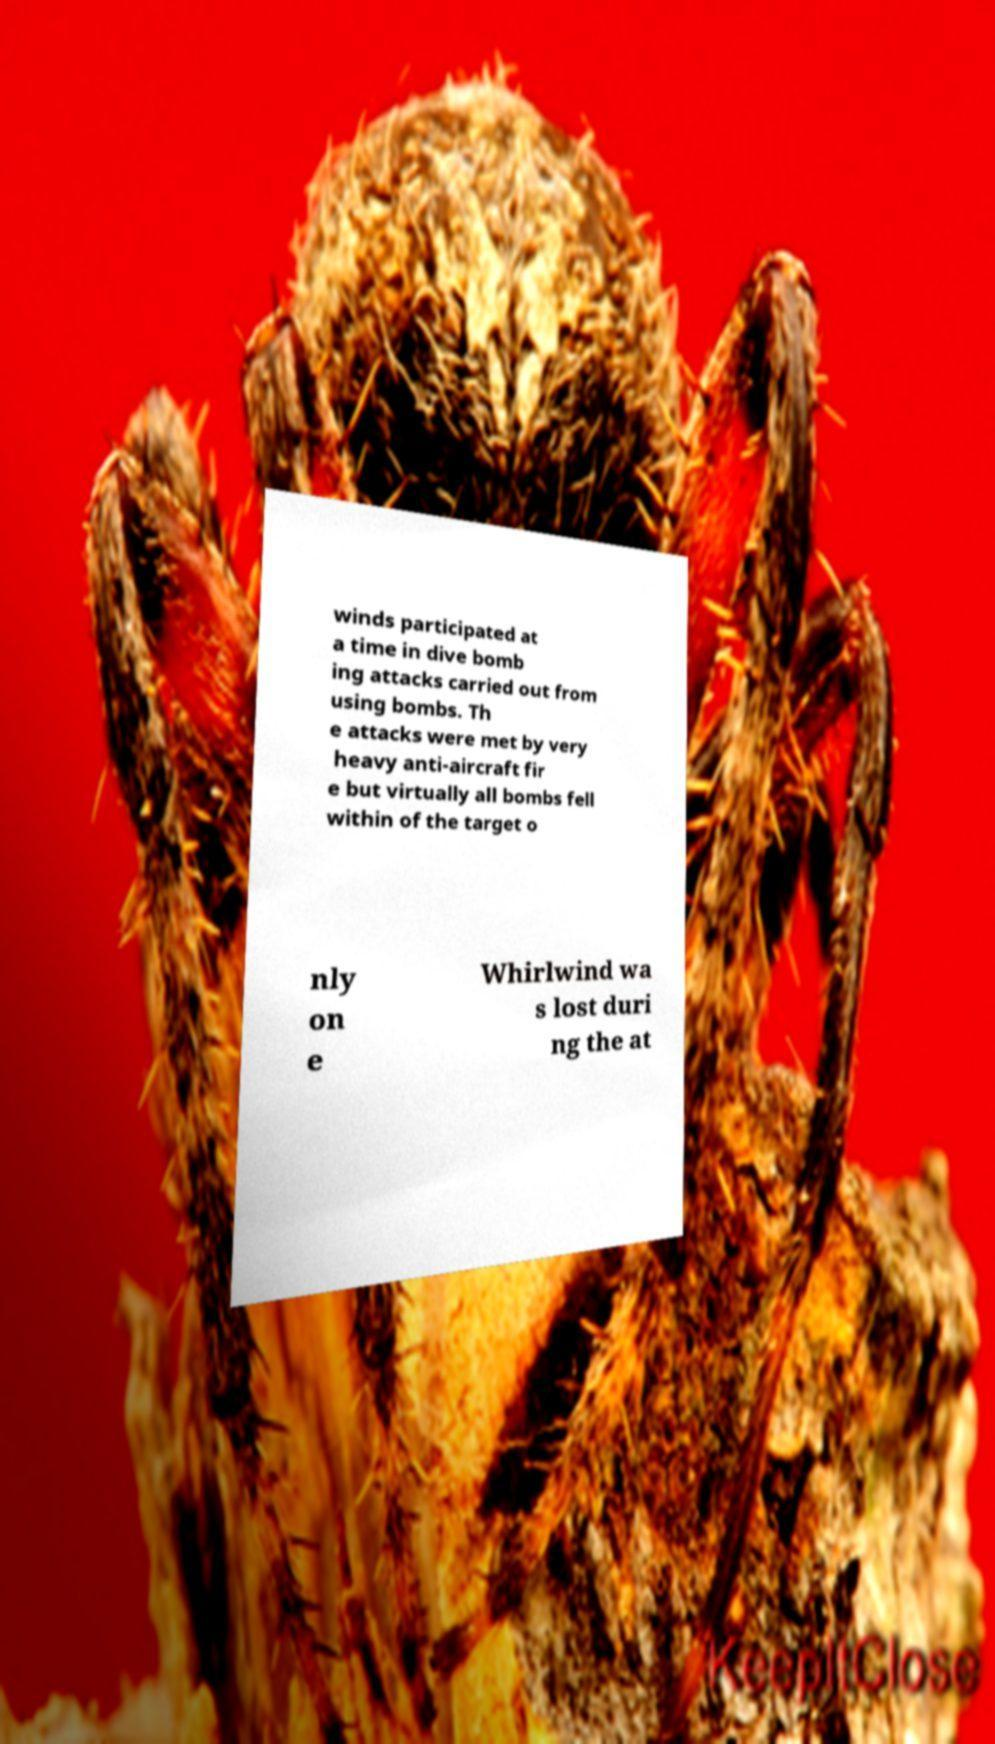Can you read and provide the text displayed in the image?This photo seems to have some interesting text. Can you extract and type it out for me? winds participated at a time in dive bomb ing attacks carried out from using bombs. Th e attacks were met by very heavy anti-aircraft fir e but virtually all bombs fell within of the target o nly on e Whirlwind wa s lost duri ng the at 